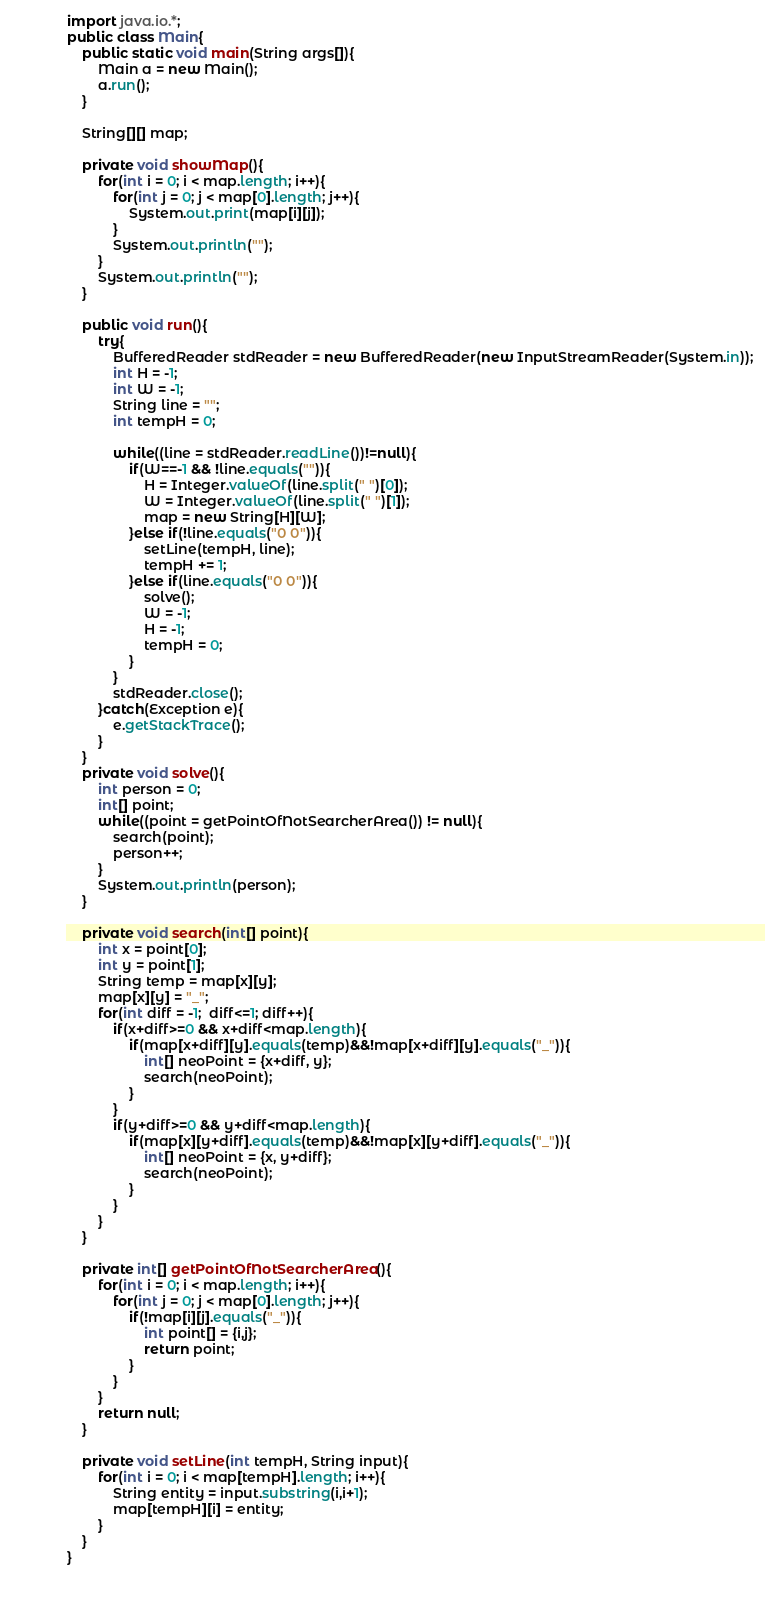Convert code to text. <code><loc_0><loc_0><loc_500><loc_500><_Java_>import java.io.*;
public class Main{
    public static void main(String args[]){
		Main a = new Main();
		a.run();
    }

    String[][] map;
    
    private void showMap(){
        for(int i = 0; i < map.length; i++){
            for(int j = 0; j < map[0].length; j++){
                System.out.print(map[i][j]);
            }
            System.out.println("");
        }
        System.out.println("");
    }
    
    public void run(){
        try{
            BufferedReader stdReader = new BufferedReader(new InputStreamReader(System.in));
            int H = -1;            
            int W = -1;            
            String line = "";
            int tempH = 0;
			
            while((line = stdReader.readLine())!=null){
                if(W==-1 && !line.equals("")){
                    H = Integer.valueOf(line.split(" ")[0]);
                    W = Integer.valueOf(line.split(" ")[1]);
                    map = new String[H][W];
                }else if(!line.equals("0 0")){
                    setLine(tempH, line);
                    tempH += 1;
                }else if(line.equals("0 0")){
					solve();
					W = -1;
					H = -1;
					tempH = 0;
				}
            }
            stdReader.close();
        }catch(Exception e){
			e.getStackTrace();
        }
    }
    private void solve(){
        int person = 0;
        int[] point;
        while((point = getPointOfNotSearcherArea()) != null){
            search(point);
            person++;
        }
        System.out.println(person);
    }
    
    private void search(int[] point){
        int x = point[0];
        int y = point[1];
        String temp = map[x][y];
        map[x][y] = "_";
        for(int diff = -1;  diff<=1; diff++){
            if(x+diff>=0 && x+diff<map.length){
                if(map[x+diff][y].equals(temp)&&!map[x+diff][y].equals("_")){
                    int[] neoPoint = {x+diff, y};
                    search(neoPoint);
                }
            }
            if(y+diff>=0 && y+diff<map.length){
                if(map[x][y+diff].equals(temp)&&!map[x][y+diff].equals("_")){
                    int[] neoPoint = {x, y+diff};
                    search(neoPoint);
                }
            }
        }
    }

    private int[] getPointOfNotSearcherArea(){
        for(int i = 0; i < map.length; i++){
            for(int j = 0; j < map[0].length; j++){
                if(!map[i][j].equals("_")){
                    int point[] = {i,j};
                    return point;
                }
            }
        }
        return null;
    }
        
    private void setLine(int tempH, String input){
        for(int i = 0; i < map[tempH].length; i++){
            String entity = input.substring(i,i+1);
            map[tempH][i] = entity;
        }
    }
}

    </code> 